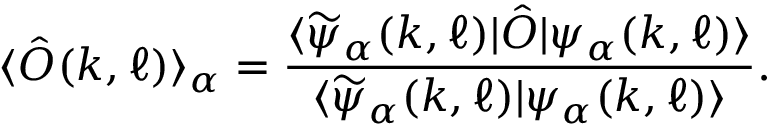<formula> <loc_0><loc_0><loc_500><loc_500>\langle \hat { O } ( k , \ell ) \rangle _ { \alpha } = \frac { \langle \widetilde { \psi } _ { \alpha } ( k , \ell ) | \hat { O } | \psi _ { \alpha } ( k , \ell ) \rangle } { \langle \widetilde { \psi } _ { \alpha } ( k , \ell ) | \psi _ { \alpha } ( k , \ell ) \rangle } .</formula> 